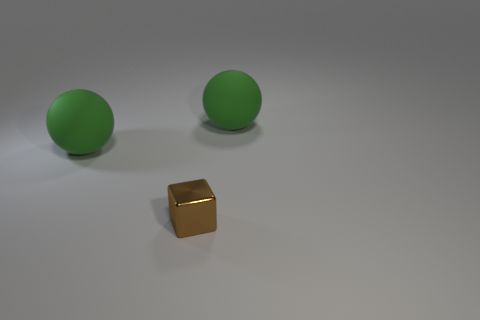Do the matte thing to the left of the cube and the brown metallic object have the same size?
Provide a succinct answer. No. Is there anything else that has the same shape as the small brown thing?
Keep it short and to the point. No. How many purple objects are either tiny metallic blocks or rubber things?
Make the answer very short. 0. Are any metal things visible?
Offer a terse response. Yes. There is a rubber sphere to the left of the ball to the right of the tiny metal cube; are there any things that are right of it?
Ensure brevity in your answer.  Yes. Is there any other thing that is the same size as the brown metal thing?
Give a very brief answer. No. Do the small thing and the green matte object that is on the right side of the tiny thing have the same shape?
Your answer should be very brief. No. The matte thing that is to the left of the tiny brown block that is in front of the green matte object that is left of the brown thing is what color?
Your answer should be very brief. Green. How many things are either green objects that are left of the tiny brown block or spheres that are to the left of the block?
Offer a very short reply. 1. How many other things are there of the same color as the small cube?
Keep it short and to the point. 0. 